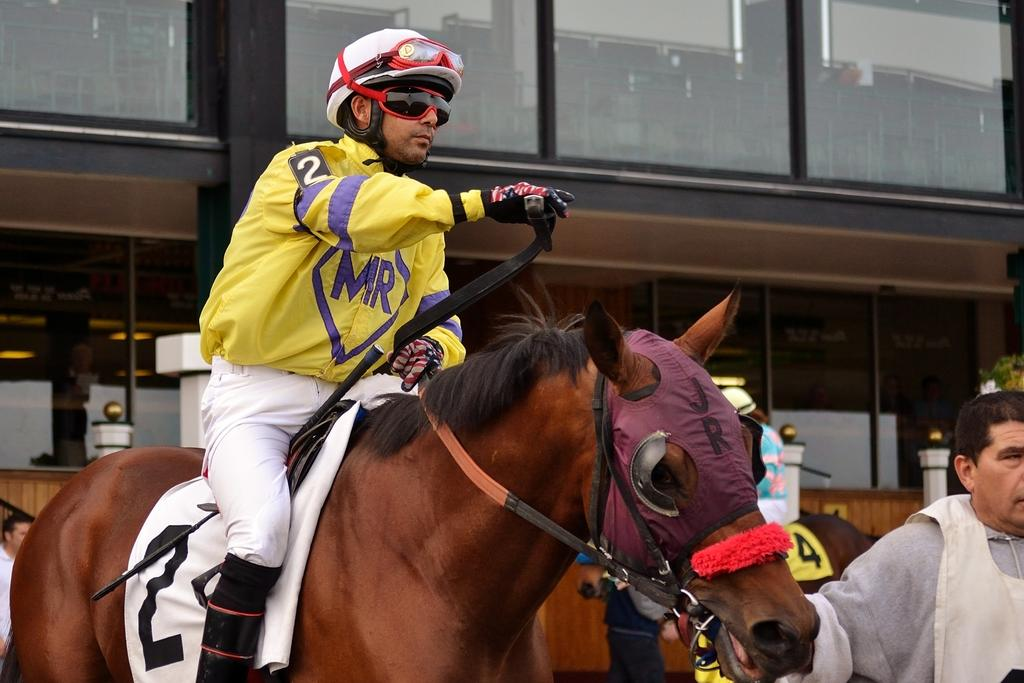What structure is visible in the image? There is a building in the image. Where is the first man located in the image? The first man is on the right side of the image. What is the second man doing in the image? The second man is sitting on a horse. How many fowl are present in the image? There are no fowl visible in the image. What type of cloud can be seen in the image? There is no cloud present in the image. 